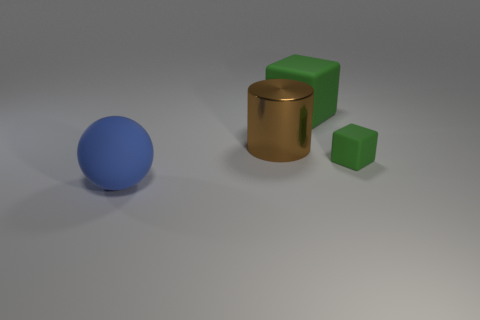Can you tell me what the largest object in the image is? The largest object in the image appears to be the brown cylinder, which has a greater volume compared to the other items. 